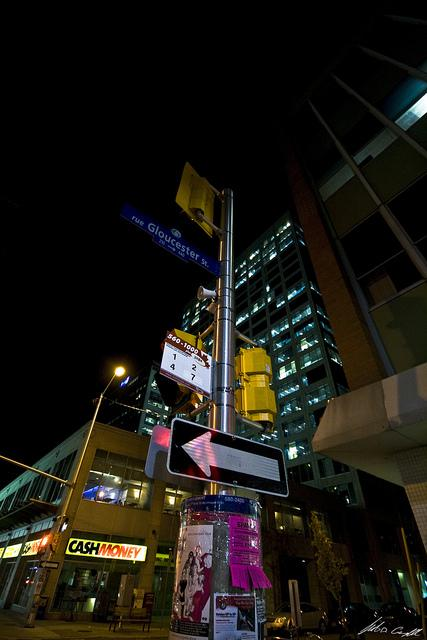What does the white arrow sign usually mean?

Choices:
A) stop
B) one way
C) no turns
D) yield one way 